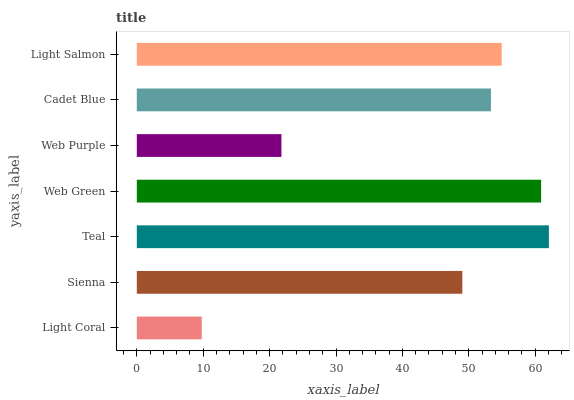Is Light Coral the minimum?
Answer yes or no. Yes. Is Teal the maximum?
Answer yes or no. Yes. Is Sienna the minimum?
Answer yes or no. No. Is Sienna the maximum?
Answer yes or no. No. Is Sienna greater than Light Coral?
Answer yes or no. Yes. Is Light Coral less than Sienna?
Answer yes or no. Yes. Is Light Coral greater than Sienna?
Answer yes or no. No. Is Sienna less than Light Coral?
Answer yes or no. No. Is Cadet Blue the high median?
Answer yes or no. Yes. Is Cadet Blue the low median?
Answer yes or no. Yes. Is Light Coral the high median?
Answer yes or no. No. Is Sienna the low median?
Answer yes or no. No. 